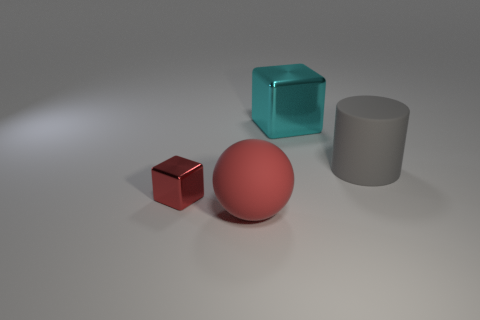Add 1 large matte balls. How many objects exist? 5 Subtract all spheres. How many objects are left? 3 Subtract 0 purple blocks. How many objects are left? 4 Subtract all tiny yellow cubes. Subtract all cyan cubes. How many objects are left? 3 Add 3 rubber balls. How many rubber balls are left? 4 Add 4 gray cylinders. How many gray cylinders exist? 5 